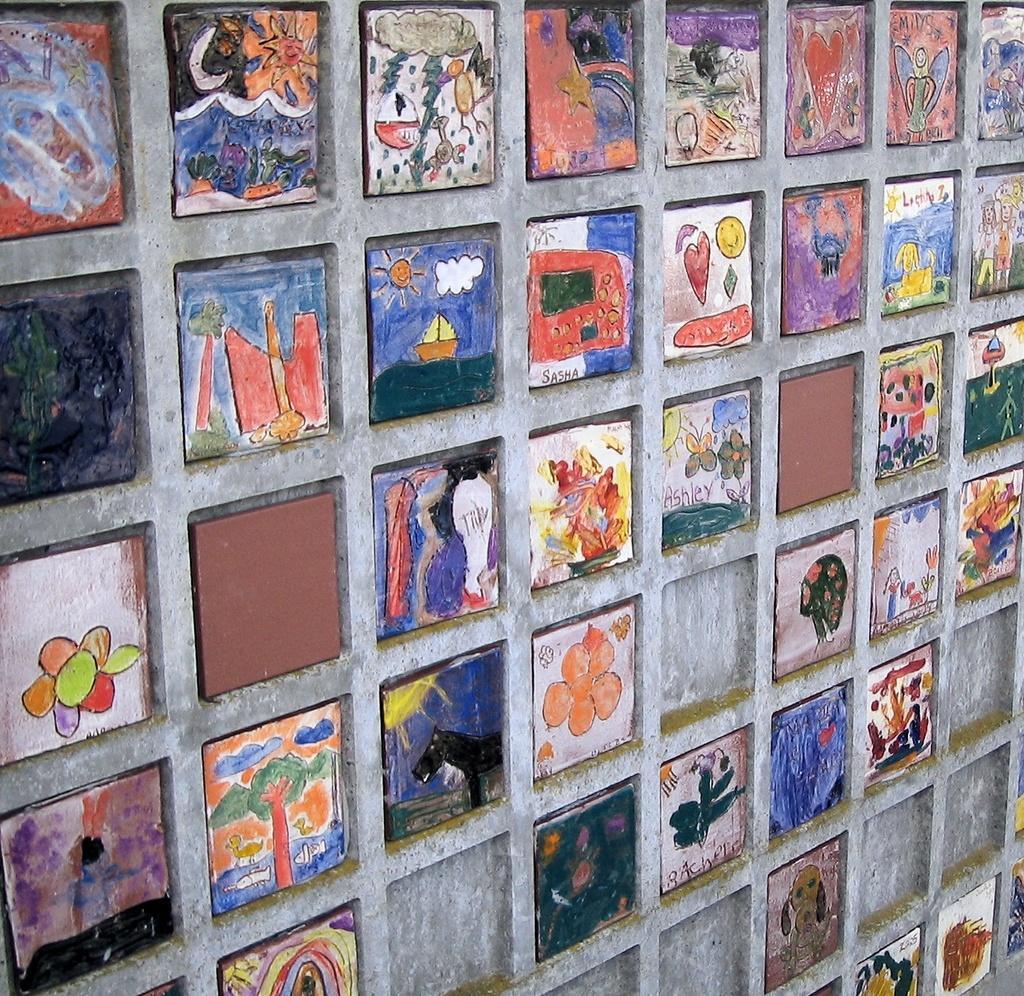Could you give a brief overview of what you see in this image? In this picture we can see few paintings on the wall. 